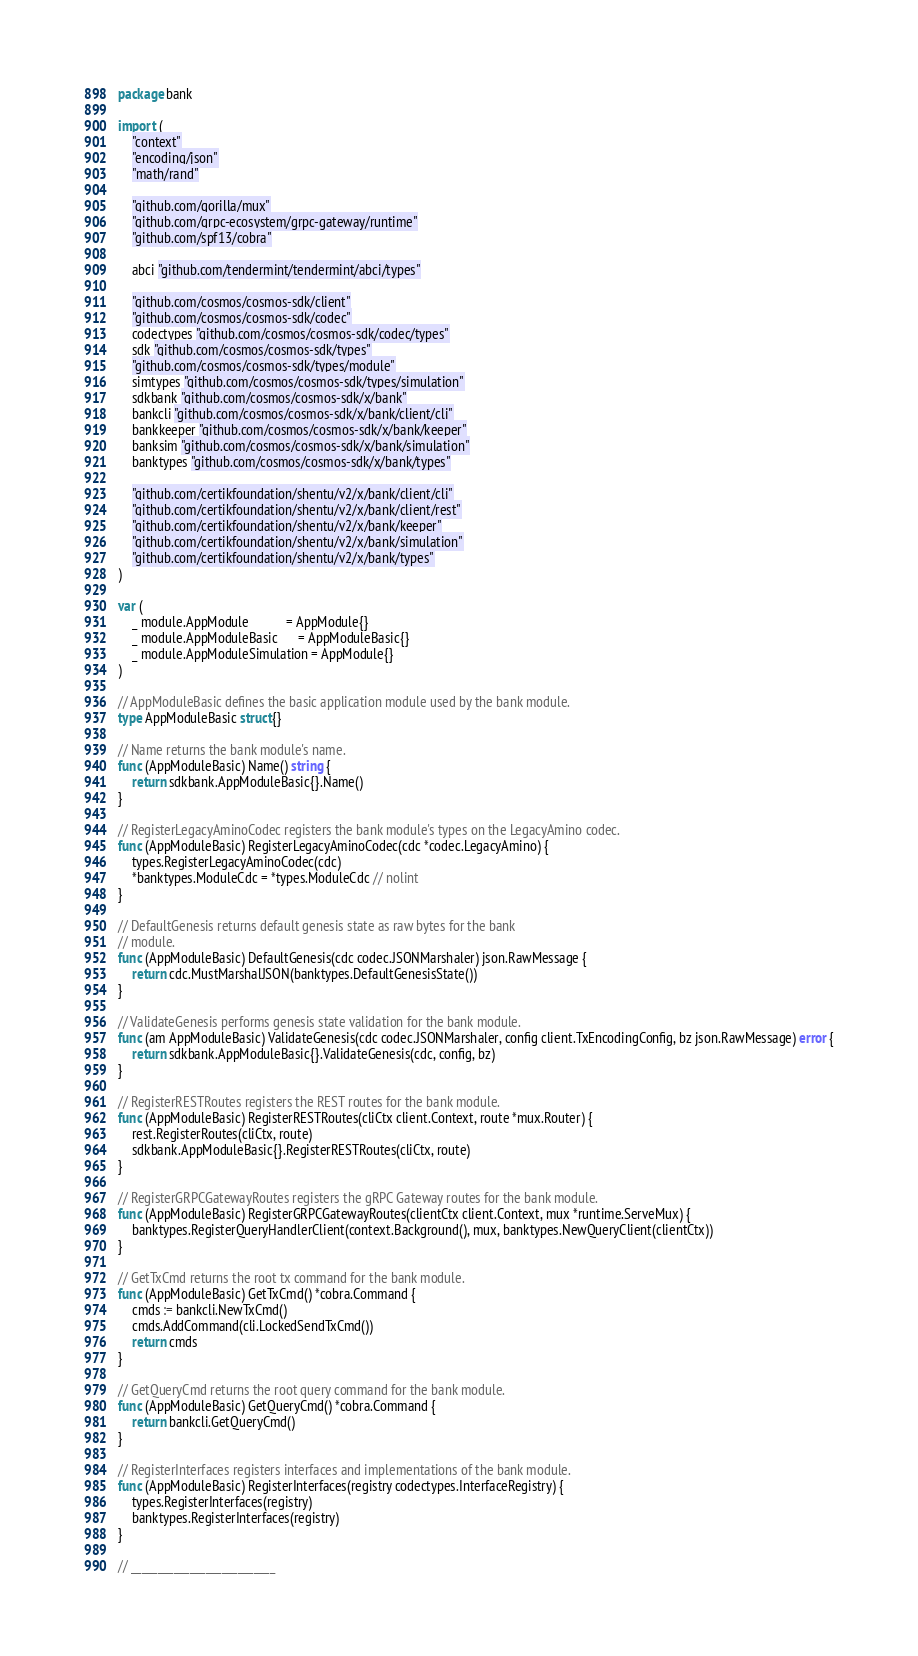Convert code to text. <code><loc_0><loc_0><loc_500><loc_500><_Go_>package bank

import (
	"context"
	"encoding/json"
	"math/rand"

	"github.com/gorilla/mux"
	"github.com/grpc-ecosystem/grpc-gateway/runtime"
	"github.com/spf13/cobra"

	abci "github.com/tendermint/tendermint/abci/types"

	"github.com/cosmos/cosmos-sdk/client"
	"github.com/cosmos/cosmos-sdk/codec"
	codectypes "github.com/cosmos/cosmos-sdk/codec/types"
	sdk "github.com/cosmos/cosmos-sdk/types"
	"github.com/cosmos/cosmos-sdk/types/module"
	simtypes "github.com/cosmos/cosmos-sdk/types/simulation"
	sdkbank "github.com/cosmos/cosmos-sdk/x/bank"
	bankcli "github.com/cosmos/cosmos-sdk/x/bank/client/cli"
	bankkeeper "github.com/cosmos/cosmos-sdk/x/bank/keeper"
	banksim "github.com/cosmos/cosmos-sdk/x/bank/simulation"
	banktypes "github.com/cosmos/cosmos-sdk/x/bank/types"

	"github.com/certikfoundation/shentu/v2/x/bank/client/cli"
	"github.com/certikfoundation/shentu/v2/x/bank/client/rest"
	"github.com/certikfoundation/shentu/v2/x/bank/keeper"
	"github.com/certikfoundation/shentu/v2/x/bank/simulation"
	"github.com/certikfoundation/shentu/v2/x/bank/types"
)

var (
	_ module.AppModule           = AppModule{}
	_ module.AppModuleBasic      = AppModuleBasic{}
	_ module.AppModuleSimulation = AppModule{}
)

// AppModuleBasic defines the basic application module used by the bank module.
type AppModuleBasic struct{}

// Name returns the bank module's name.
func (AppModuleBasic) Name() string {
	return sdkbank.AppModuleBasic{}.Name()
}

// RegisterLegacyAminoCodec registers the bank module's types on the LegacyAmino codec.
func (AppModuleBasic) RegisterLegacyAminoCodec(cdc *codec.LegacyAmino) {
	types.RegisterLegacyAminoCodec(cdc)
	*banktypes.ModuleCdc = *types.ModuleCdc // nolint
}

// DefaultGenesis returns default genesis state as raw bytes for the bank
// module.
func (AppModuleBasic) DefaultGenesis(cdc codec.JSONMarshaler) json.RawMessage {
	return cdc.MustMarshalJSON(banktypes.DefaultGenesisState())
}

// ValidateGenesis performs genesis state validation for the bank module.
func (am AppModuleBasic) ValidateGenesis(cdc codec.JSONMarshaler, config client.TxEncodingConfig, bz json.RawMessage) error {
	return sdkbank.AppModuleBasic{}.ValidateGenesis(cdc, config, bz)
}

// RegisterRESTRoutes registers the REST routes for the bank module.
func (AppModuleBasic) RegisterRESTRoutes(cliCtx client.Context, route *mux.Router) {
	rest.RegisterRoutes(cliCtx, route)
	sdkbank.AppModuleBasic{}.RegisterRESTRoutes(cliCtx, route)
}

// RegisterGRPCGatewayRoutes registers the gRPC Gateway routes for the bank module.
func (AppModuleBasic) RegisterGRPCGatewayRoutes(clientCtx client.Context, mux *runtime.ServeMux) {
	banktypes.RegisterQueryHandlerClient(context.Background(), mux, banktypes.NewQueryClient(clientCtx))
}

// GetTxCmd returns the root tx command for the bank module.
func (AppModuleBasic) GetTxCmd() *cobra.Command {
	cmds := bankcli.NewTxCmd()
	cmds.AddCommand(cli.LockedSendTxCmd())
	return cmds
}

// GetQueryCmd returns the root query command for the bank module.
func (AppModuleBasic) GetQueryCmd() *cobra.Command {
	return bankcli.GetQueryCmd()
}

// RegisterInterfaces registers interfaces and implementations of the bank module.
func (AppModuleBasic) RegisterInterfaces(registry codectypes.InterfaceRegistry) {
	types.RegisterInterfaces(registry)
	banktypes.RegisterInterfaces(registry)
}

// ___________________________
</code> 